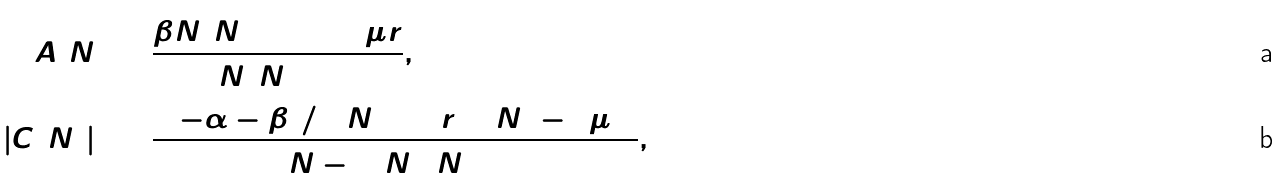<formula> <loc_0><loc_0><loc_500><loc_500>\hat { A } ( \hat { N } ) & = \frac { \beta \hat { N } ( \hat { N } + 2 ) + 8 \mu r } { 2 \hat { N } ( \hat { N } + 2 ) } , \\ | \hat { C } ( \hat { N } ) | ^ { 2 } & = \frac { ( ( - \alpha - \beta ^ { 2 } / 4 ) \hat { N } ^ { 2 } + 4 r ^ { 2 } ) ( \hat { N } ^ { 2 } - 4 \mu ^ { 2 } ) } { 4 ( \hat { N } - 1 ) \hat { N } ^ { 2 } ( \hat { N } + 1 ) } ,</formula> 